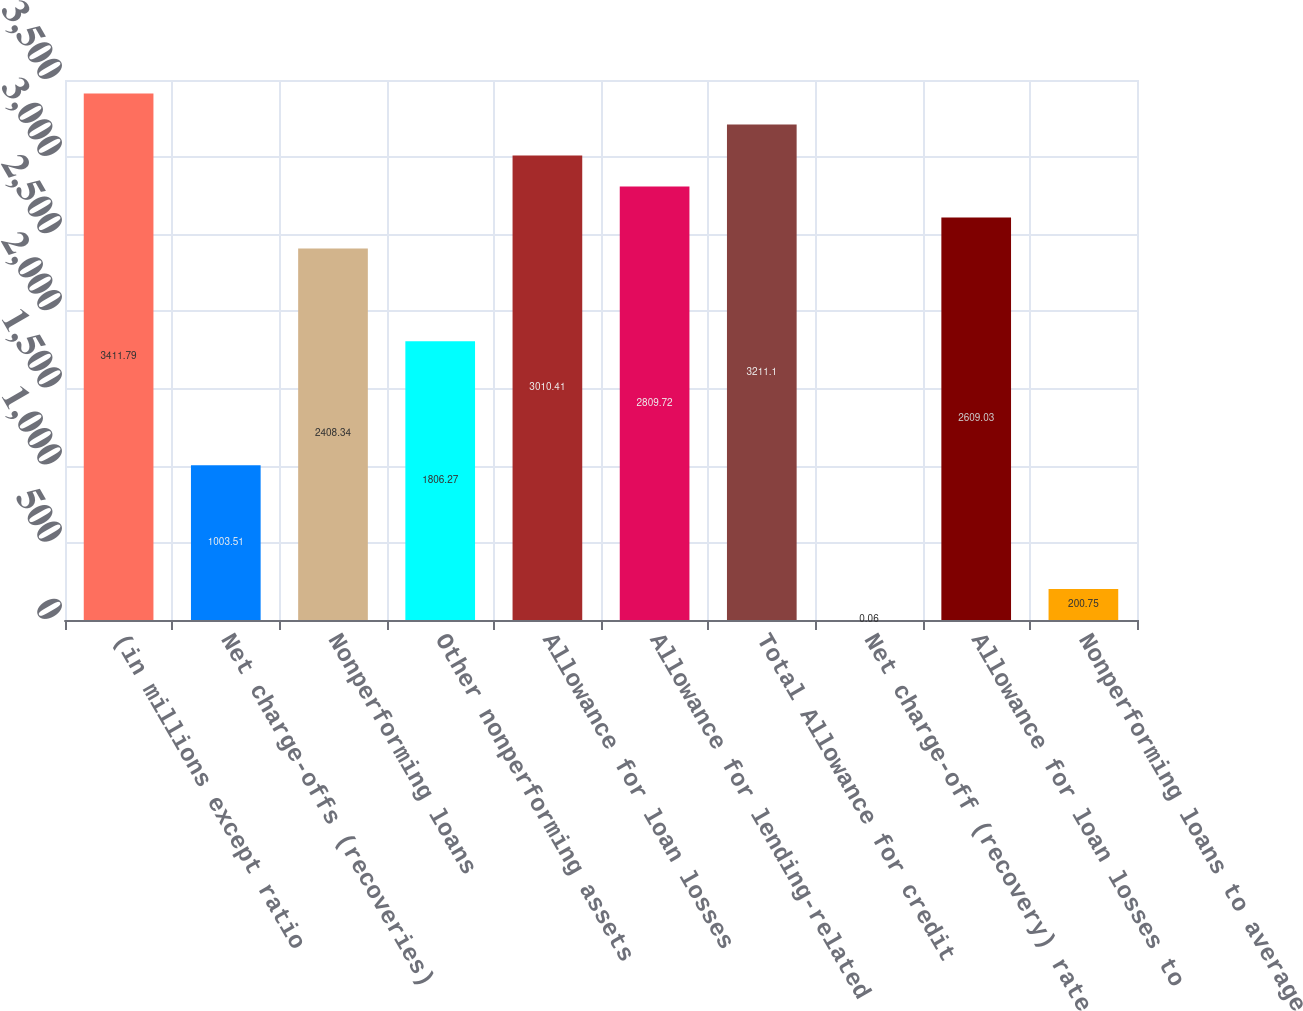Convert chart. <chart><loc_0><loc_0><loc_500><loc_500><bar_chart><fcel>(in millions except ratio<fcel>Net charge-offs (recoveries)<fcel>Nonperforming loans<fcel>Other nonperforming assets<fcel>Allowance for loan losses<fcel>Allowance for lending-related<fcel>Total Allowance for credit<fcel>Net charge-off (recovery) rate<fcel>Allowance for loan losses to<fcel>Nonperforming loans to average<nl><fcel>3411.79<fcel>1003.51<fcel>2408.34<fcel>1806.27<fcel>3010.41<fcel>2809.72<fcel>3211.1<fcel>0.06<fcel>2609.03<fcel>200.75<nl></chart> 